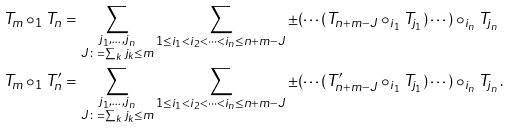<formula> <loc_0><loc_0><loc_500><loc_500>T _ { m } \circ _ { 1 } T _ { n } & = \sum _ { \substack { j _ { 1 } , \dots , j _ { n } \\ J \colon = \sum _ { k } j _ { k } \leq m } } \sum _ { 1 \leq i _ { 1 } < i _ { 2 } < \cdots < i _ { n } \leq n + m - J } \pm ( \cdots ( T _ { n + m - J } \circ _ { i _ { 1 } } T _ { j _ { 1 } } ) \cdots ) \circ _ { i _ { n } } T _ { j _ { n } } \\ T _ { m } \circ _ { 1 } T _ { n } ^ { \prime } & = \sum _ { \substack { j _ { 1 } , \dots , j _ { n } \\ J \colon = \sum _ { k } j _ { k } \leq m } } \sum _ { 1 \leq i _ { 1 } < i _ { 2 } < \cdots < i _ { n } \leq n + m - J } \pm ( \cdots ( T _ { n + m - J } ^ { \prime } \circ _ { i _ { 1 } } T _ { j _ { 1 } } ) \cdots ) \circ _ { i _ { n } } T _ { j _ { n } } \, .</formula> 